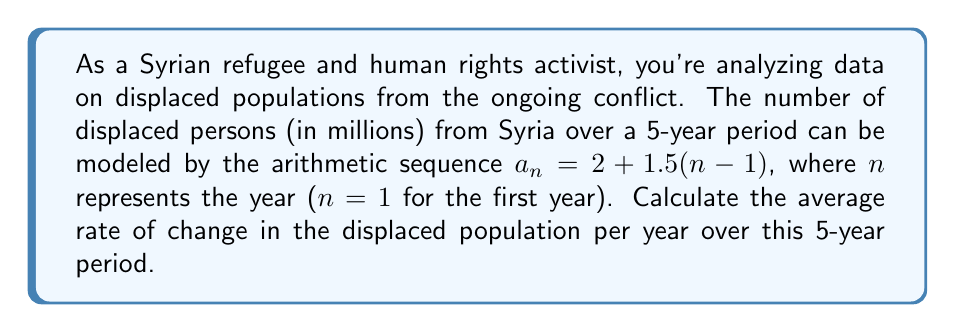Solve this math problem. To solve this problem, we'll follow these steps:

1) First, let's find the number of displaced persons at the beginning and end of the 5-year period:

   For n = 1 (first year): $a_1 = 2 + 1.5(1-1) = 2$ million
   For n = 5 (fifth year): $a_5 = 2 + 1.5(5-1) = 2 + 1.5(4) = 8$ million

2) The total change in population over the 5-year period is:
   
   $\text{Total change} = a_5 - a_1 = 8 - 2 = 6$ million

3) To find the average rate of change per year, we divide the total change by the number of years:

   $\text{Average rate of change} = \frac{\text{Total change}}{\text{Number of years}} = \frac{6}{5-1} = \frac{6}{4} = 1.5$ million per year

4) We can verify this result by noting that in an arithmetic sequence, the common difference represents the rate of change between consecutive terms. In this case, the common difference is 1.5, which matches our calculated average rate of change.

This rate of 1.5 million people per year represents the average increase in displaced persons from Syria each year over the given 5-year period, highlighting the severe humanitarian crisis resulting from the conflict.
Answer: The average rate of change in the displaced population is 1.5 million people per year. 